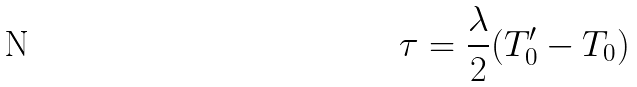Convert formula to latex. <formula><loc_0><loc_0><loc_500><loc_500>\tau = \frac { \lambda } { 2 } ( T _ { 0 } ^ { \prime } - T _ { 0 } )</formula> 